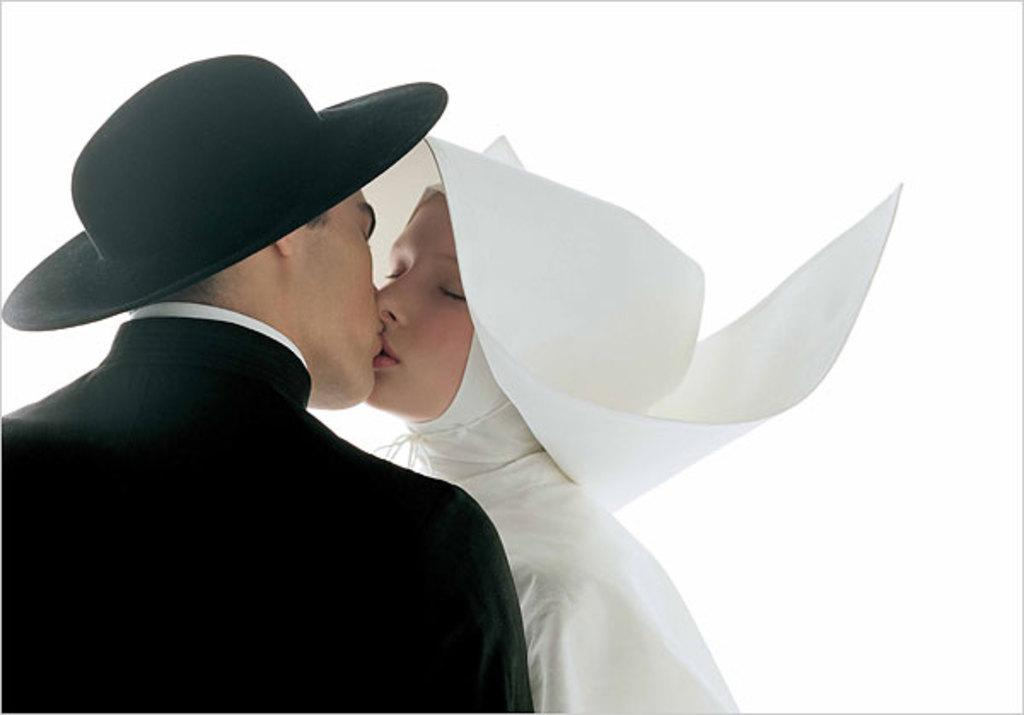Who is present in the image? There is a man in the image. What is the man wearing? The man is wearing a black suit. What is the man doing in the image? The man is kissing a woman. What is the woman wearing in the image? The woman is wearing a white dress. What is the background of the image? There is a white background in the image. How many babies are being held by the man in the image? There are no babies present in the image; the man is kissing a woman. What type of sail is visible in the image? There is no sail present in the image; it features a man in a black suit kissing a woman against a white background. 